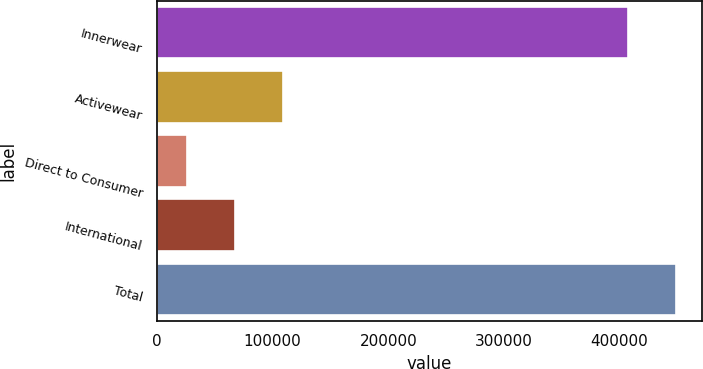Convert chart to OTSL. <chart><loc_0><loc_0><loc_500><loc_500><bar_chart><fcel>Innerwear<fcel>Activewear<fcel>Direct to Consumer<fcel>International<fcel>Total<nl><fcel>407318<fcel>108735<fcel>25890<fcel>67312.5<fcel>448740<nl></chart> 